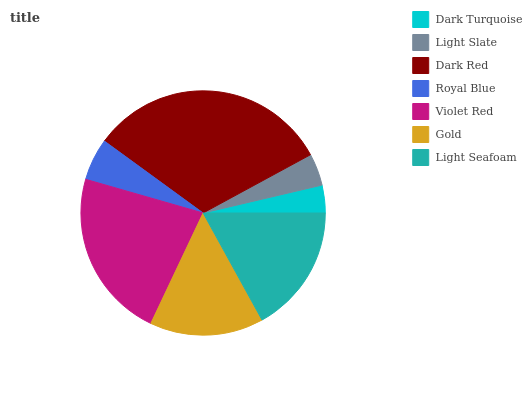Is Dark Turquoise the minimum?
Answer yes or no. Yes. Is Dark Red the maximum?
Answer yes or no. Yes. Is Light Slate the minimum?
Answer yes or no. No. Is Light Slate the maximum?
Answer yes or no. No. Is Light Slate greater than Dark Turquoise?
Answer yes or no. Yes. Is Dark Turquoise less than Light Slate?
Answer yes or no. Yes. Is Dark Turquoise greater than Light Slate?
Answer yes or no. No. Is Light Slate less than Dark Turquoise?
Answer yes or no. No. Is Gold the high median?
Answer yes or no. Yes. Is Gold the low median?
Answer yes or no. Yes. Is Light Seafoam the high median?
Answer yes or no. No. Is Light Slate the low median?
Answer yes or no. No. 